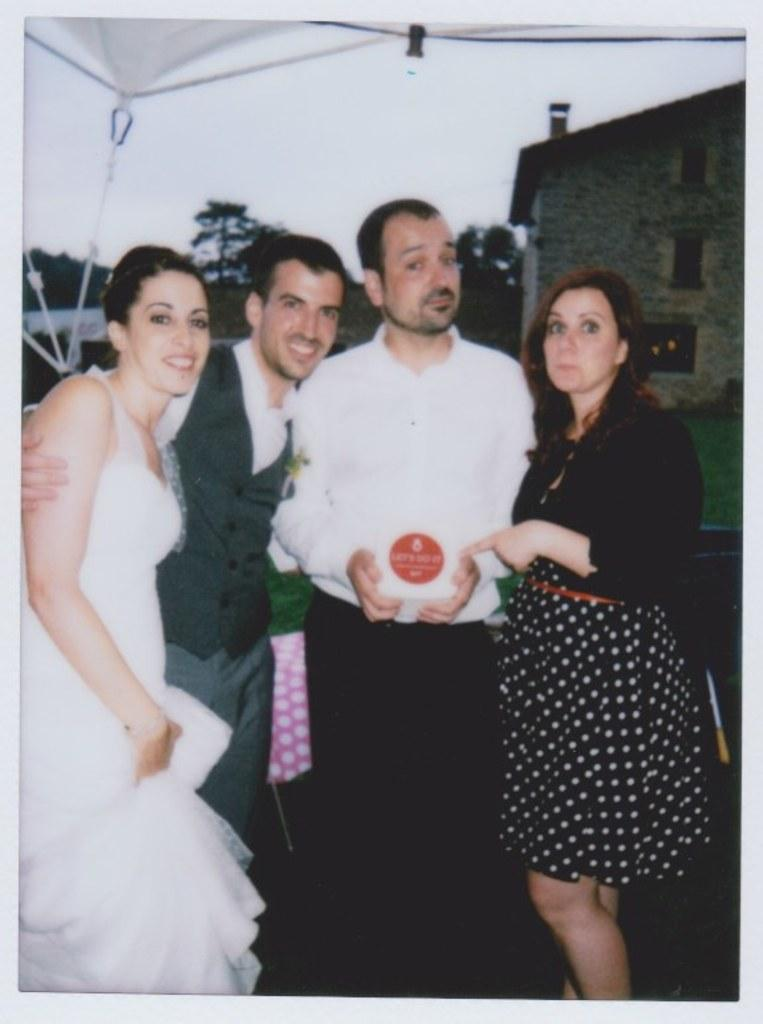What is depicted in the photocopy that is visible in the image? There is a photocopy of people in the image. What type of structure can be seen in the image? There is a house in the image. What type of vegetation is present in the image? There are trees in the image. What is visible in the background of the image? The sky is visible in the image. What type of terrain is present in the image? There is ground with grass in the image. What type of temporary shelter is present in the image? There is a tent in the image. Where is the dock located in the image? There is no dock present in the image. What type of system is used to store the people in the photocopy? The photocopy is a two-dimensional representation of people and does not require a storage system. 